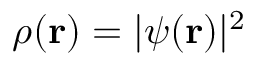Convert formula to latex. <formula><loc_0><loc_0><loc_500><loc_500>\rho ( { r } ) = | \psi ( { r } ) | ^ { 2 }</formula> 